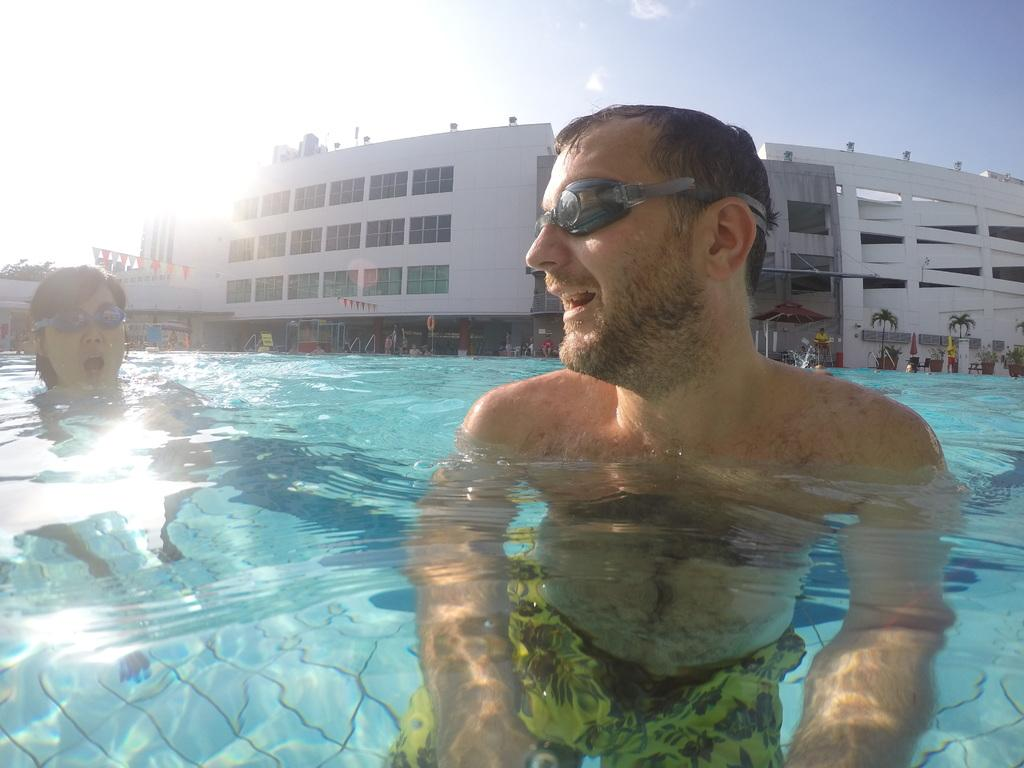How many people are in the water in the image? There are two persons in the water in the image. What can be seen in the background of the image? There are trees, buildings, and other objects visible in the background of the image. Where can the kittens be found in the image? There are no kittens present in the image. What type of seed is being used to grow the trees in the image? The image does not provide information about the type of seed used to grow the trees, nor does it show any seeds. 